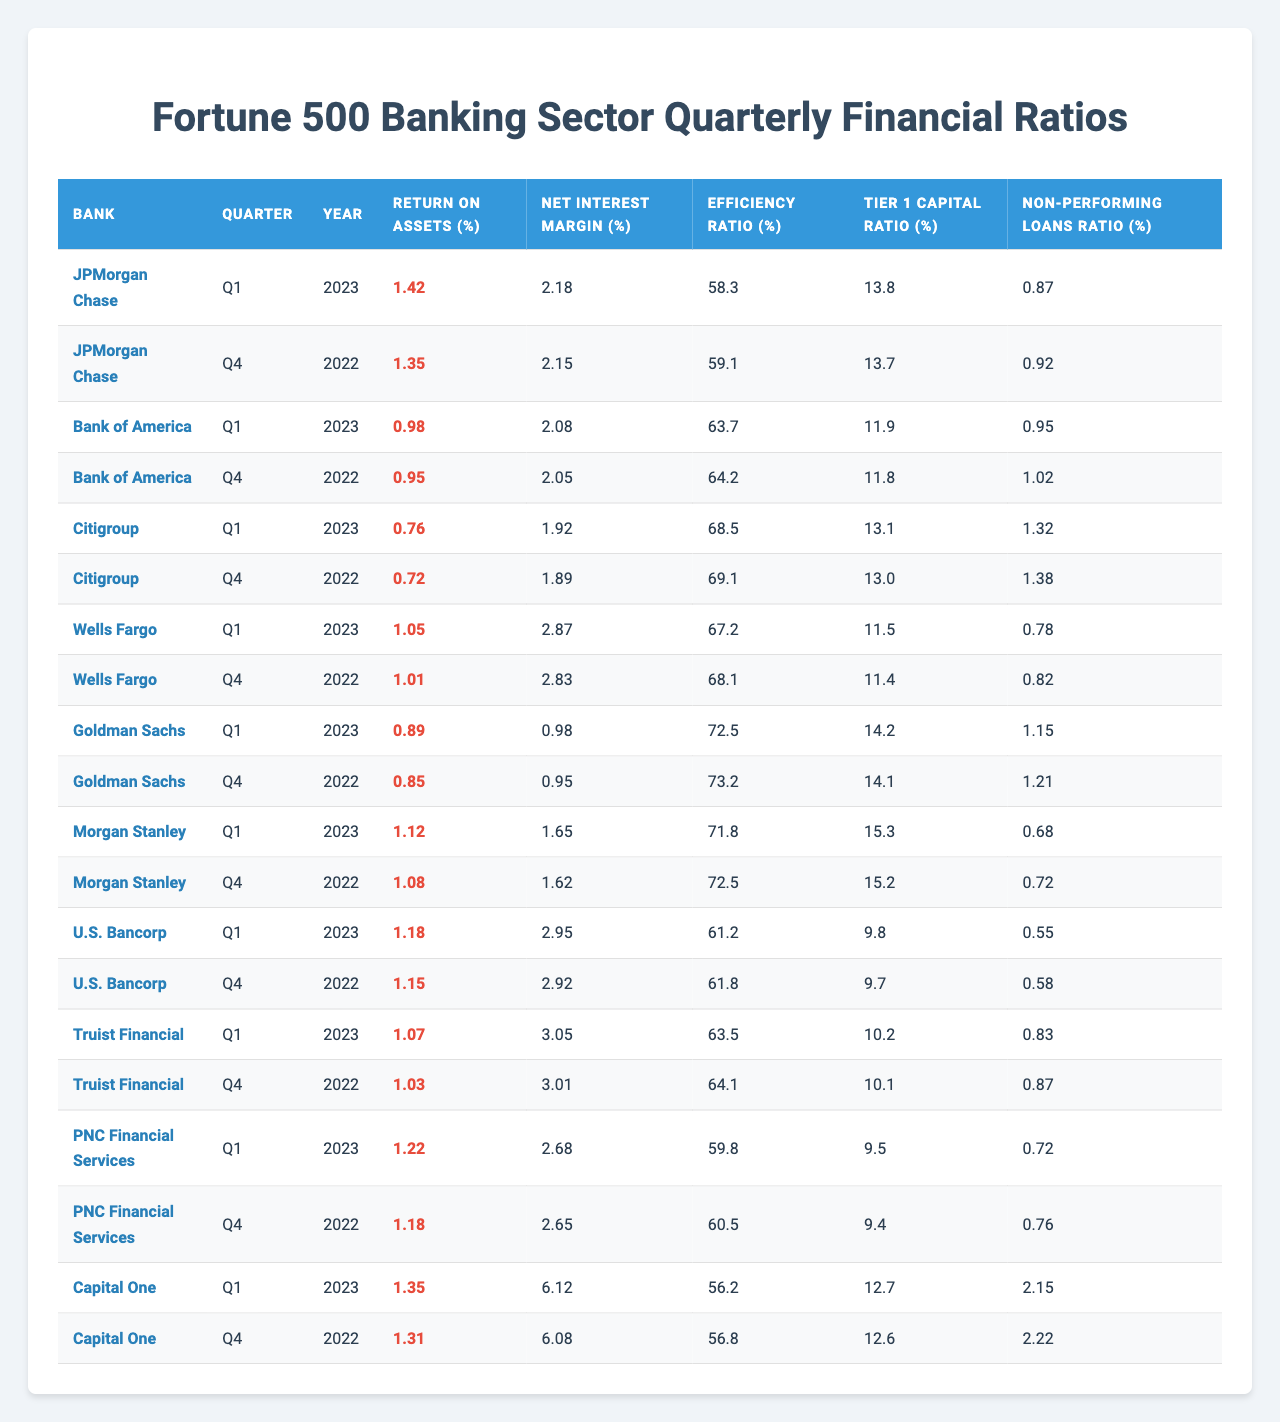What is the Return on Assets for JPMorgan Chase in Q1 2023? The table shows that the Return on Assets for JPMorgan Chase in Q1 2023 is listed as 1.42%.
Answer: 1.42% Which bank has the highest Net Interest Margin in Q1 2023? From the table, Capital One has the highest Net Interest Margin at 6.12% in Q1 2023.
Answer: Capital One What is the Efficiency Ratio of Citigroup in Q4 2022? The Efficiency Ratio for Citigroup in Q4 2022 is found in the table as 69.1%.
Answer: 69.1% Is the Non-Performing Loans Ratio for Wells Fargo higher in Q1 2023 compared to Q4 2022? The Non-Performing Loans Ratio for Wells Fargo is 0.78% in Q4 2022 and 0.78% in Q1 2023, indicating no change. Therefore, the statement is false.
Answer: No What is the difference in Return on Assets between Bank of America in Q1 2023 and Q4 2022? In Q1 2023, Bank of America’s Return on Assets is 0.98% and in Q4 2022 it is 0.95%. The difference is 0.98% - 0.95% = 0.03%.
Answer: 0.03% Which two banks have an Efficiency Ratio greater than 70% in Q1 2023? The table shows that Citigroup (68.5%) and Goldman Sachs (72.5%) both exceed a 70% Efficiency Ratio. However, only Goldman Sachs meets the criteria.
Answer: Goldman Sachs only What is the average Tier 1 Capital Ratio for the banks listed in Q1 2023? The Tier 1 Capital Ratios listed are: 13.8, 11.9, 13.1, 11.5, 14.2, 15.3, 9.8, 10.2, 9.5, 12.7. Adding these values gives a sum of 136.5, and there are 10 data points, so the average is 136.5 / 10 = 13.65%.
Answer: 13.65% For which bank is the Non-Performing Loans Ratio the lowest in Q1 2023? From the table, U.S. Bancorp has the lowest Non-Performing Loans Ratio at 0.55% in Q1 2023.
Answer: U.S. Bancorp How many banks have a Net Interest Margin of 2.5% or higher in Q1 2023? The Net Interest Margins that meet this criterion are: 2.18%, 2.08%, 2.87%, 2.95%, 3.05%, 6.12%. There are 6 banks listed with margins of 2.5% or higher.
Answer: 6 Does Citigroup have a lower efficiency ratio than PNC Financial Services in Q1 2023? Citigroup's Efficiency Ratio in Q1 2023 is 68.5% while PNC Financial Services is at 59.8%. Therefore, Citigroup does not have a lower ratio; it is higher.
Answer: No 